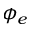Convert formula to latex. <formula><loc_0><loc_0><loc_500><loc_500>\phi _ { e }</formula> 